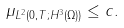<formula> <loc_0><loc_0><loc_500><loc_500>\| \mu \| _ { L ^ { 2 } ( 0 , T ; H ^ { 3 } ( \Omega ) ) } \leq c .</formula> 